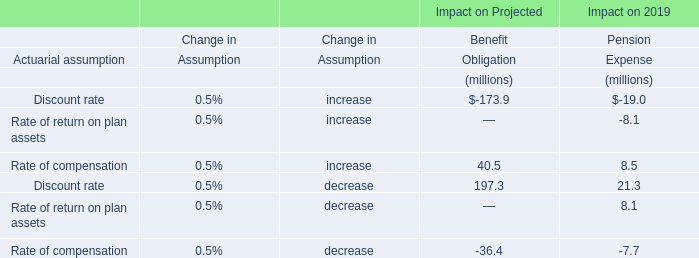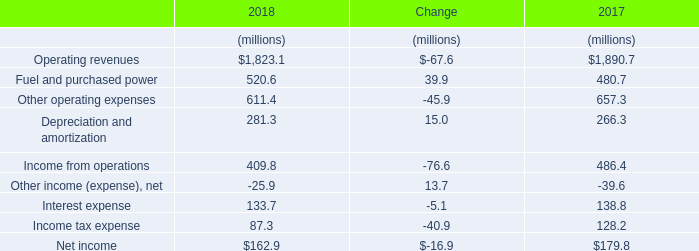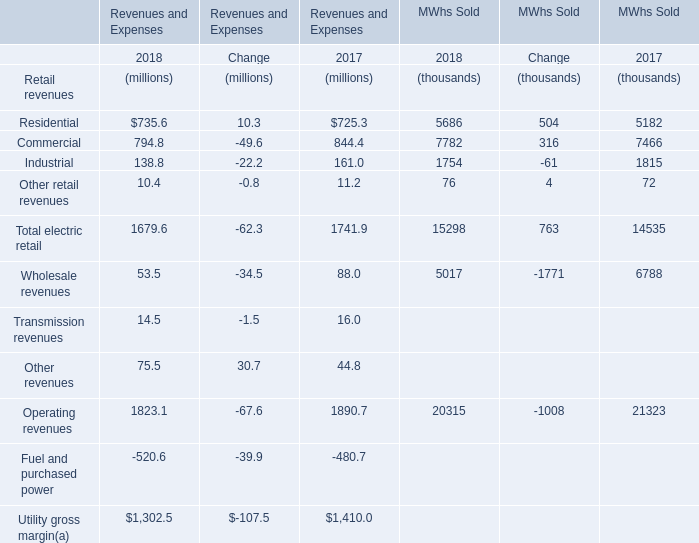What is the proportion of Residential to the total electric retail in 2018? 
Computations: (735.6 / 1679.6)
Answer: 0.43796. 